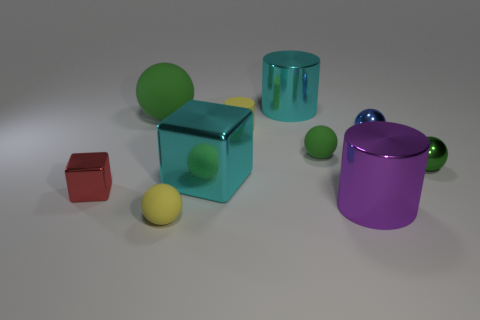Subtract all red cylinders. How many green spheres are left? 3 Subtract all small green rubber spheres. How many spheres are left? 4 Subtract all yellow spheres. How many spheres are left? 4 Subtract 2 balls. How many balls are left? 3 Subtract all gray balls. Subtract all yellow blocks. How many balls are left? 5 Subtract all cylinders. How many objects are left? 7 Subtract 0 green cylinders. How many objects are left? 10 Subtract all green metal balls. Subtract all green metallic objects. How many objects are left? 8 Add 4 tiny shiny blocks. How many tiny shiny blocks are left? 5 Add 1 tiny green matte things. How many tiny green matte things exist? 2 